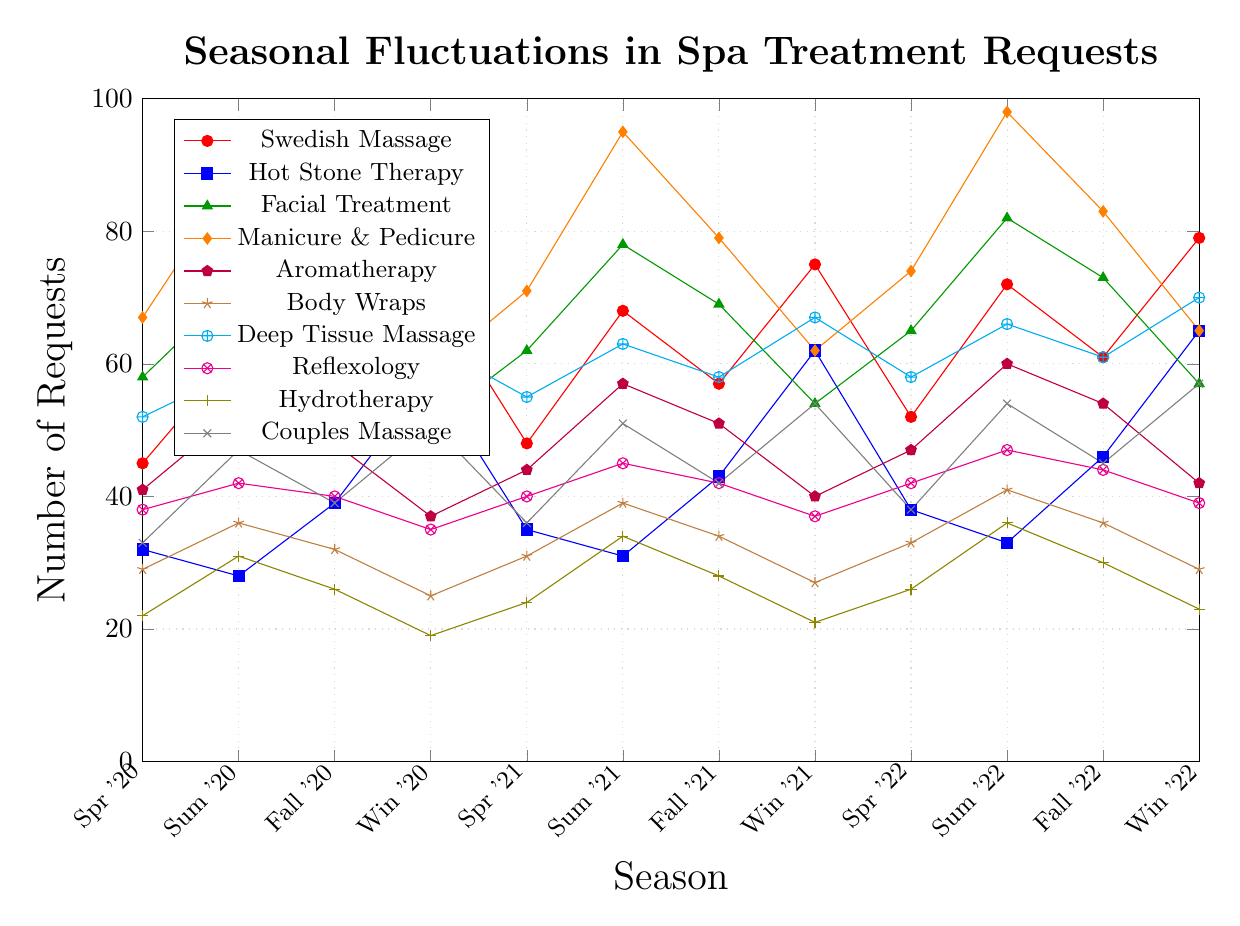Which treatment had the highest number of requests in Summer 2022? First, look for the data points related to Summer 2022. Compare each line’s height on the graph for Summer 2022. The highest point corresponds to the treatment with the most requests. Manicure & Pedicure had 98 requests in Summer 2022, making it the highest.
Answer: Manicure & Pedicure Which treatment showed the most significant increase in requests from Spring 2020 to Summer 2020? Find the difference for each treatment between Spring 2020 and Summer 2020. Manicure & Pedicure increased from 67 to 89, a rise of 22, which is the largest increase among the treatments.
Answer: Manicure & Pedicure What is the average number of requests for Swedish Massage across all seasons? Sum all the data points for Swedish Massage and divide by the number of seasons: (45 + 62 + 53 + 71 + 48 + 68 + 57 + 75 + 52 + 72 + 61 + 79) = 743. There are 12 seasons; 743 / 12 = 61.92.
Answer: 61.92 Which treatment’s number of requests fluctuated the most over the 3-year period? Identify the range for each treatment by subtracting the minimum number of requests from the maximum across all seasons. Manicure & Pedicure fluctuated between 59 and 98, a range of 39, which is the largest among all treatments.
Answer: Manicure & Pedicure Were there any treatments that had a consistent seasonal trend every year? Look for patterns that repeat each season for each year. Swedish Massage illustrates a somewhat consistent pattern, gradually increasing through the seasons each year.
Answer: Swedish Massage In Winter 2021, which treatment had close to an equal number of requests? Compare the number of requests for each treatment in Winter 2021, particularly looking for similar values. Swedish Massage (75) and Facial Treatment (54) have distinctly different values, however, Deep Tissue Massage (67) and Couples Massage (54) are closer in values.
Answer: Not particularly How did the popularity of Aromatherapy change from Summer 2020 to Winter 2020? Observe the graph points for Aromatherapy from Summer 2020 to Winter 2020. In Summer 2020, Aromatherapy had 53 requests and then dropped to 37 requests in Winter 2020.
Answer: It decreased Between Spring 2020 and Winter 2022, how did the number of requests for Hydrotherapy change? Look at the data points for Hydrotherapy, Spring 2020 (22), and Winter 2022 (23). The change is 23 - 22 = 1, indicating a small increase.
Answer: Increased by 1 Which treatment had the lowest number of requests in any season throughout the period? Identify the minimum value across all treatments and seasons. Hydrotherapy had 19 requests in Winter 2020, the lowest number among all treatments and seasons.
Answer: Hydrotherapy in Winter 2020 Which season in 2022 showed a peak in spa treatment requests for Deep Tissue Massage? Review the data points for Deep Tissue Massage in each season of 2022. The line for Deep Tissue Massage peaks at 70 requests in Winter 2022.
Answer: Winter 2022 